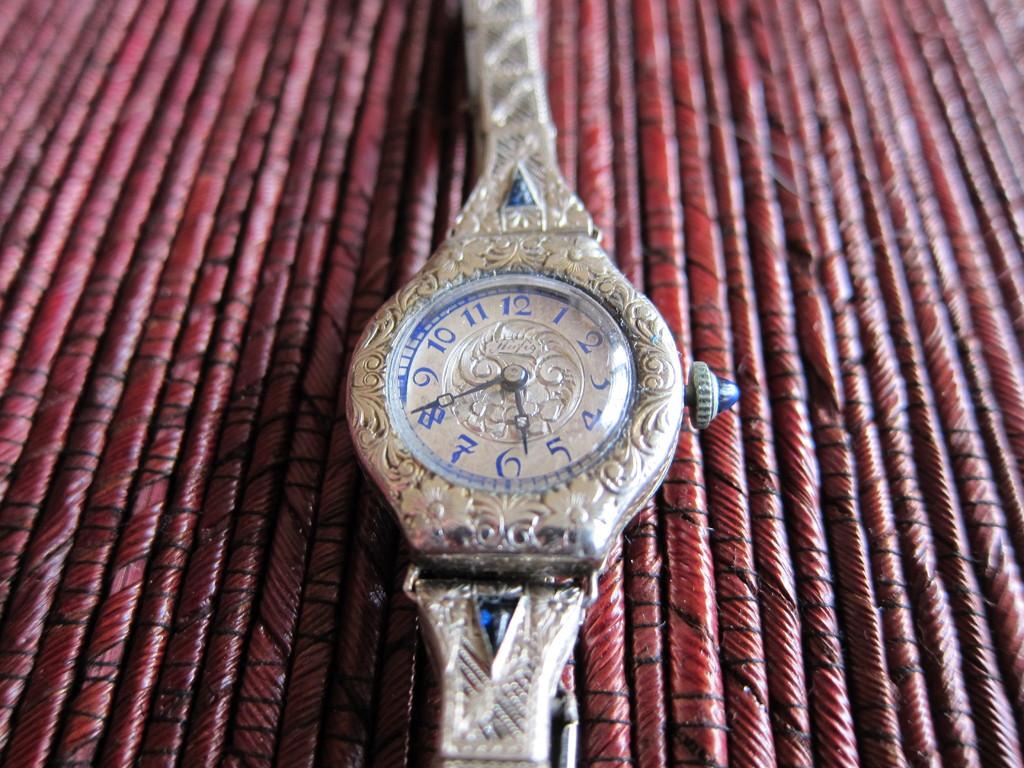What is the time shown?
Provide a succinct answer. 5:40. What number is the big hand closest to?
Provide a succinct answer. 8. 